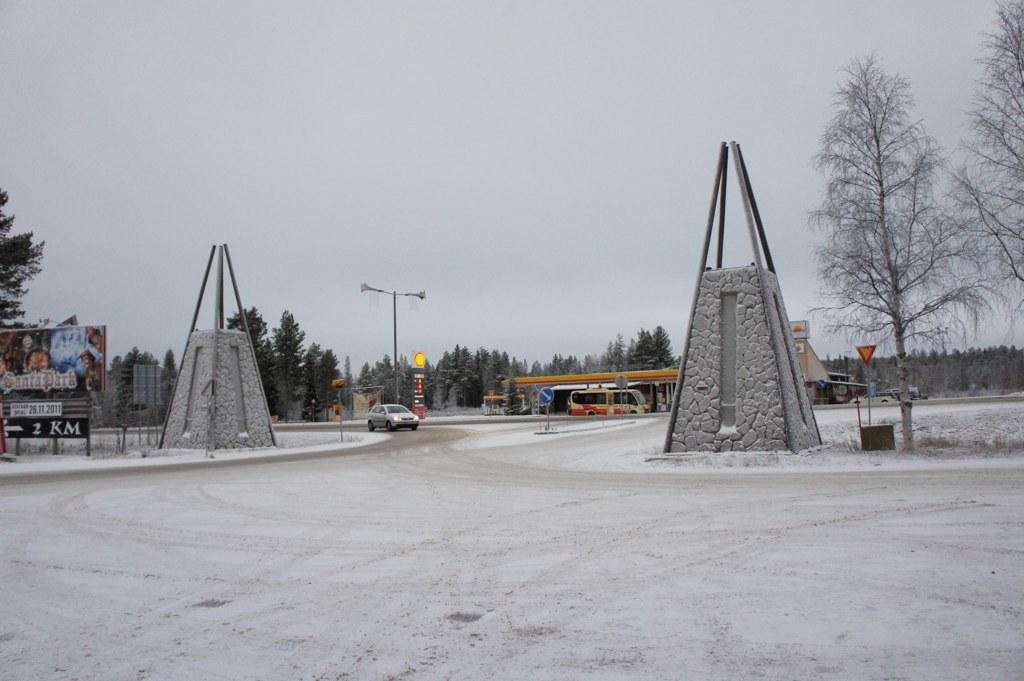What type of objects can be seen in the image? There are memorial stones, rods, a hoarding, a sign board, a light pole, and vehicles in the image. What is the purpose of the rods associated with the memorial stones? The rods are likely used to support or decorate the memorial stones. What can be found on the sign board in the image? The content of the sign board cannot be determined from the image. What type of vegetation is present in the image? There are trees in the image. What is visible in the background of the image? The sky is visible in the background of the image. Can you hear the group of goldfish coughing in the image? There are no goldfish or sounds present in the image, so it is not possible to hear them coughing. 